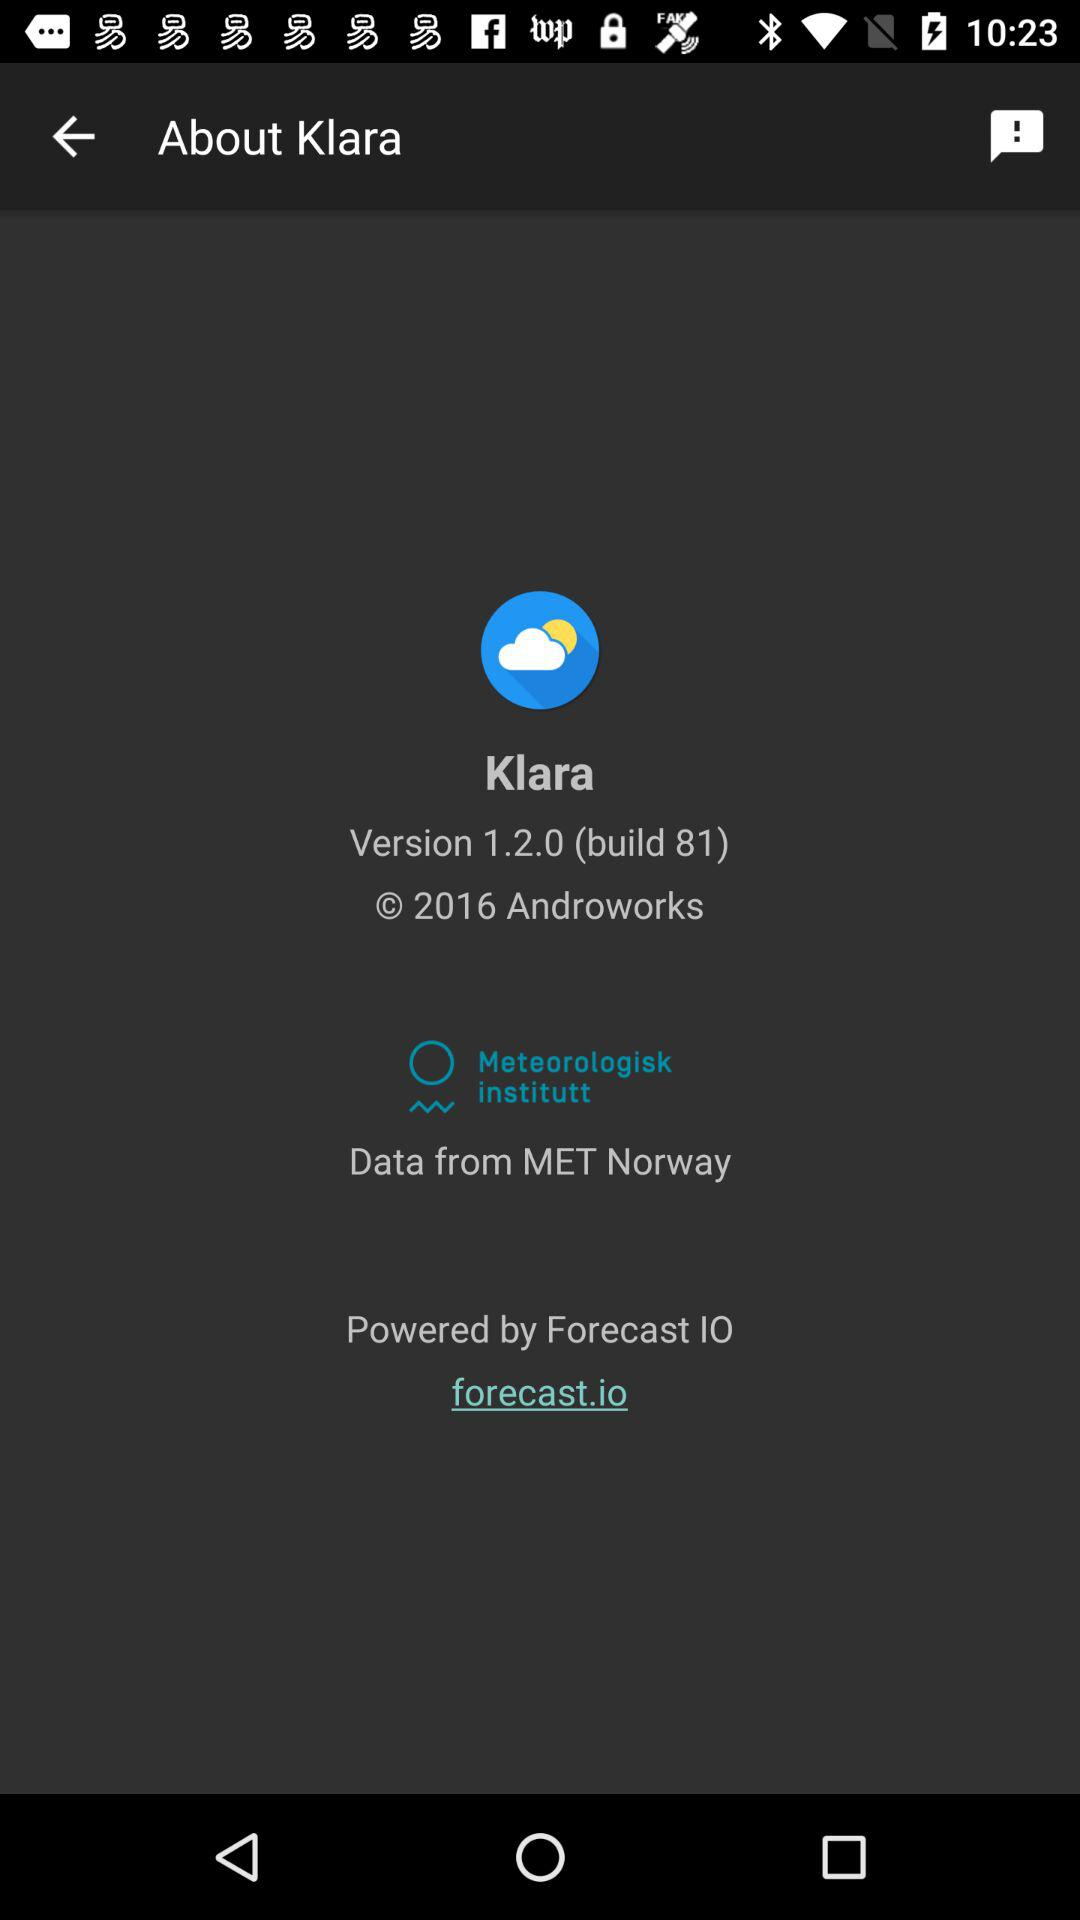What is the copyright year? The copyright year is 2016. 